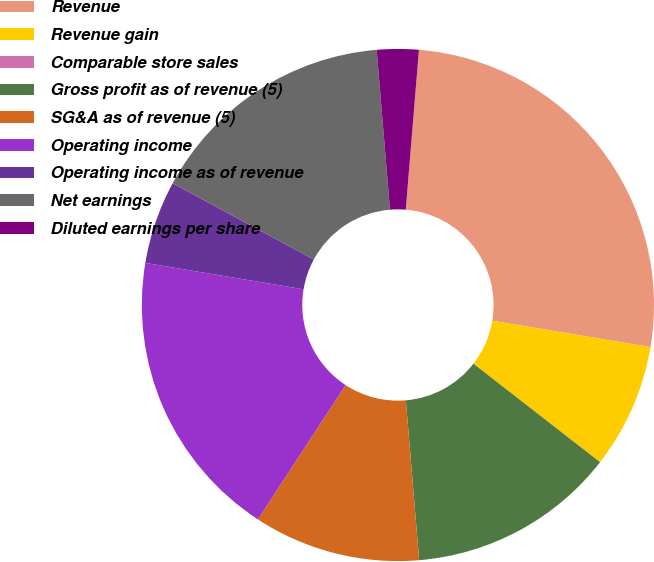Convert chart to OTSL. <chart><loc_0><loc_0><loc_500><loc_500><pie_chart><fcel>Revenue<fcel>Revenue gain<fcel>Comparable store sales<fcel>Gross profit as of revenue (5)<fcel>SG&A as of revenue (5)<fcel>Operating income<fcel>Operating income as of revenue<fcel>Net earnings<fcel>Diluted earnings per share<nl><fcel>26.32%<fcel>7.89%<fcel>0.0%<fcel>13.16%<fcel>10.53%<fcel>18.42%<fcel>5.26%<fcel>15.79%<fcel>2.63%<nl></chart> 